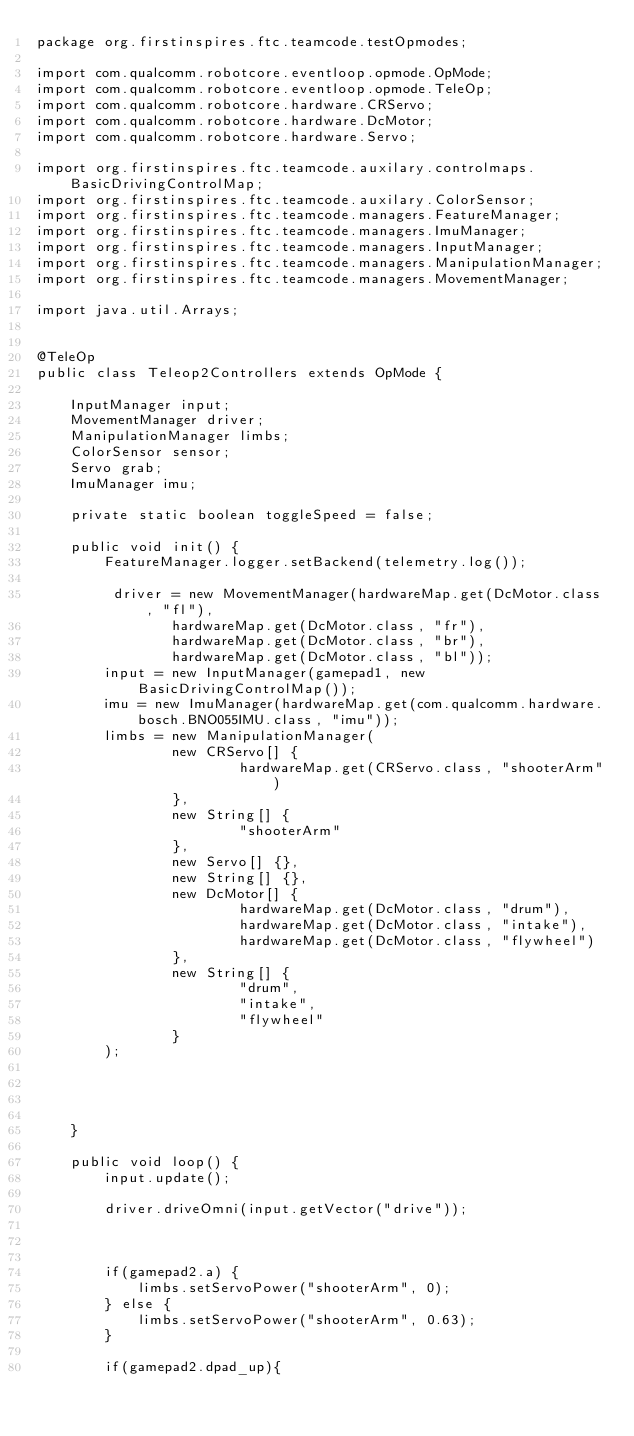Convert code to text. <code><loc_0><loc_0><loc_500><loc_500><_Java_>package org.firstinspires.ftc.teamcode.testOpmodes;

import com.qualcomm.robotcore.eventloop.opmode.OpMode;
import com.qualcomm.robotcore.eventloop.opmode.TeleOp;
import com.qualcomm.robotcore.hardware.CRServo;
import com.qualcomm.robotcore.hardware.DcMotor;
import com.qualcomm.robotcore.hardware.Servo;

import org.firstinspires.ftc.teamcode.auxilary.controlmaps.BasicDrivingControlMap;
import org.firstinspires.ftc.teamcode.auxilary.ColorSensor;
import org.firstinspires.ftc.teamcode.managers.FeatureManager;
import org.firstinspires.ftc.teamcode.managers.ImuManager;
import org.firstinspires.ftc.teamcode.managers.InputManager;
import org.firstinspires.ftc.teamcode.managers.ManipulationManager;
import org.firstinspires.ftc.teamcode.managers.MovementManager;

import java.util.Arrays;


@TeleOp
public class Teleop2Controllers extends OpMode {

    InputManager input;
    MovementManager driver;
    ManipulationManager limbs;
    ColorSensor sensor;
    Servo grab;
    ImuManager imu;

    private static boolean toggleSpeed = false;

    public void init() {
        FeatureManager.logger.setBackend(telemetry.log());

         driver = new MovementManager(hardwareMap.get(DcMotor.class, "fl"),
                hardwareMap.get(DcMotor.class, "fr"),
                hardwareMap.get(DcMotor.class, "br"),
                hardwareMap.get(DcMotor.class, "bl"));
        input = new InputManager(gamepad1, new BasicDrivingControlMap());
        imu = new ImuManager(hardwareMap.get(com.qualcomm.hardware.bosch.BNO055IMU.class, "imu"));
        limbs = new ManipulationManager(
                new CRServo[] {
                        hardwareMap.get(CRServo.class, "shooterArm")
                },
                new String[] {
                        "shooterArm"
                },
                new Servo[] {},
                new String[] {},
                new DcMotor[] {
                        hardwareMap.get(DcMotor.class, "drum"),
                        hardwareMap.get(DcMotor.class, "intake"),
                        hardwareMap.get(DcMotor.class, "flywheel")
                },
                new String[] {
                        "drum",
                        "intake",
                        "flywheel"
                }
        );




    }

    public void loop() {
        input.update();

        driver.driveOmni(input.getVector("drive"));



        if(gamepad2.a) {
            limbs.setServoPower("shooterArm", 0);
        } else {
            limbs.setServoPower("shooterArm", 0.63);
        }

        if(gamepad2.dpad_up){</code> 